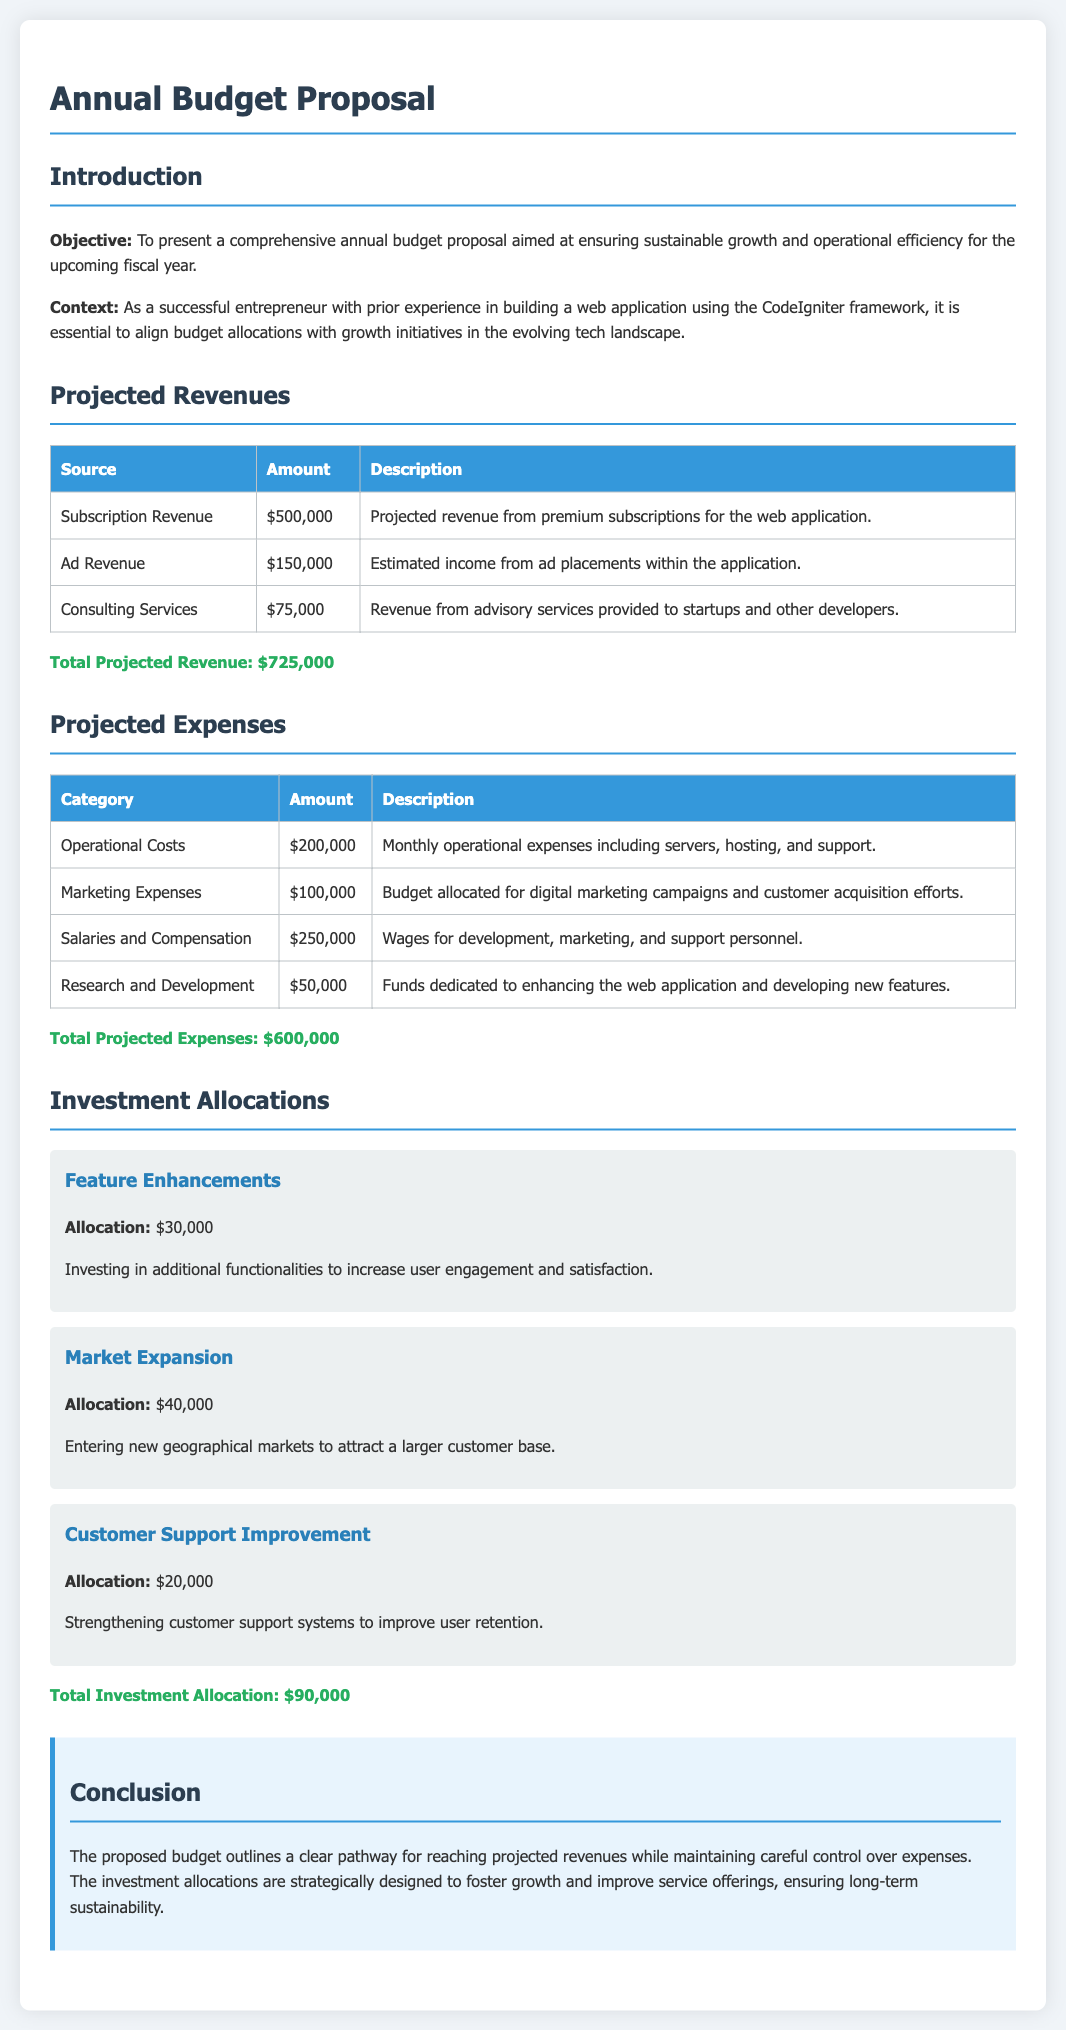What is the total projected revenue? The total projected revenue is calculated from the sum of all revenue sources listed in the document, which amounts to $500,000 + $150,000 + $75,000.
Answer: $725,000 What are the salaries and compensation expenses? This category reflects the wages for development, marketing, and support personnel detailed in the expense table.
Answer: $250,000 What is the allocation for feature enhancements? The document specifies the amount dedicated to enhancing features aimed at increasing user engagement and satisfaction.
Answer: $30,000 How much is budgeted for marketing expenses? This amount is specified for digital marketing campaigns and customer acquisition efforts within the expense table.
Answer: $100,000 What is the total amount allocated for investments? The total investment allocation is the cumulative sum of all detailed investment categories in the document.
Answer: $90,000 What is the objective of the budget proposal? The objective is presented early in the document, outlining the purpose of the budget proposal.
Answer: To present a comprehensive annual budget proposal aimed at ensuring sustainable growth and operational efficiency for the upcoming fiscal year What type of revenue comes from advising services? This revenue type is specified under consulting services in the projected revenues section.
Answer: Consulting Services What are the operational costs? The operational costs are detailed as monthly operational expenses including servers, hosting, and support.
Answer: $200,000 